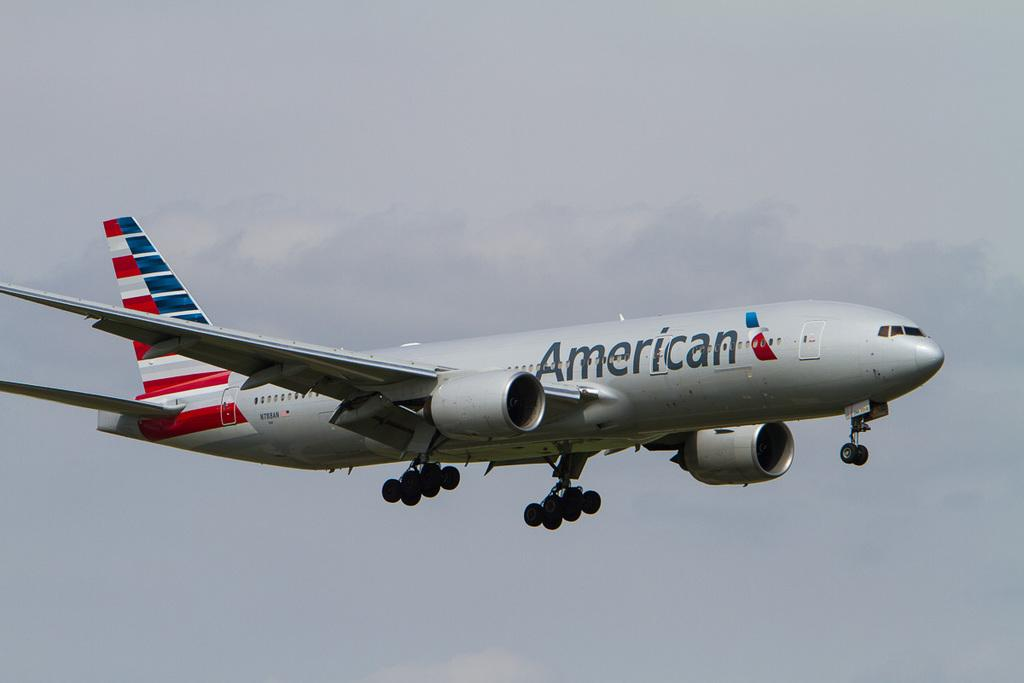What is the main subject of the image? The main subject of the image is an airplane. What is visible in the background of the image? There is a sky visible in the image. Who is the owner of the ant in the image? There is no ant present in the image, so it is not possible to determine the owner. 